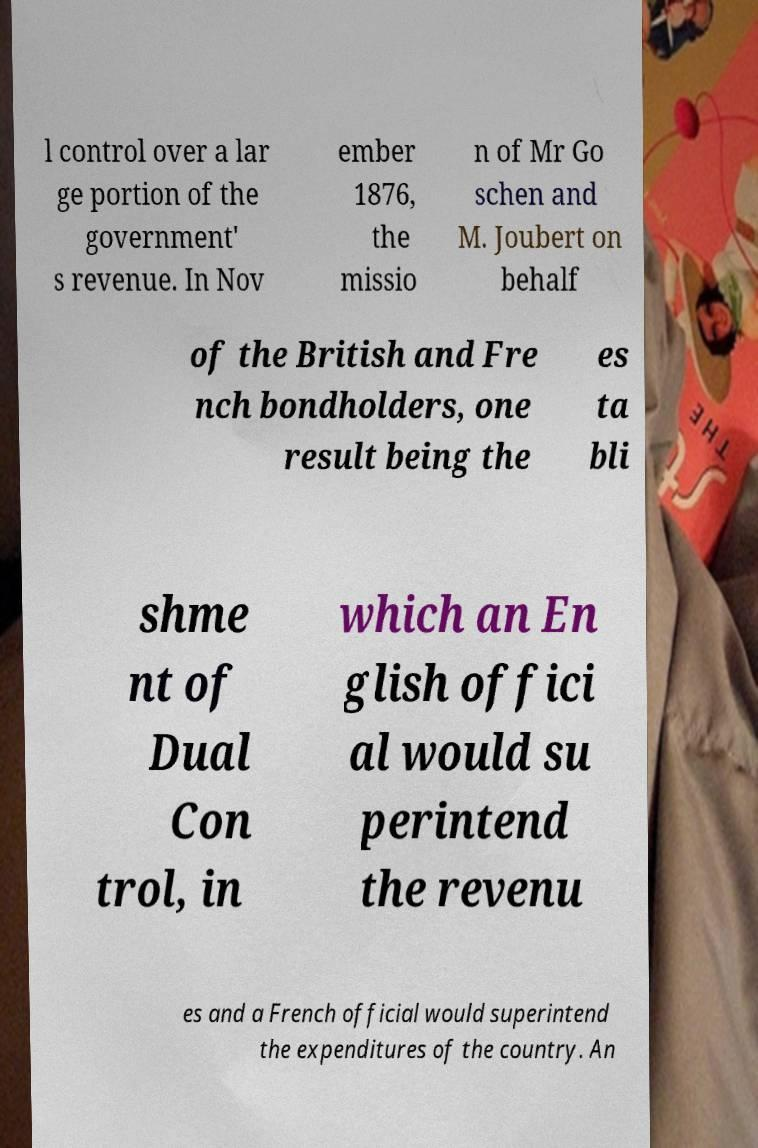Can you accurately transcribe the text from the provided image for me? l control over a lar ge portion of the government' s revenue. In Nov ember 1876, the missio n of Mr Go schen and M. Joubert on behalf of the British and Fre nch bondholders, one result being the es ta bli shme nt of Dual Con trol, in which an En glish offici al would su perintend the revenu es and a French official would superintend the expenditures of the country. An 